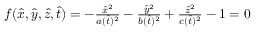<formula> <loc_0><loc_0><loc_500><loc_500>\begin{array} { r } { f ( \hat { x } , \hat { y } , \hat { z } , \hat { t } ) = - \frac { \hat { x } ^ { 2 } } { a ( \hat { t } ) ^ { 2 } } - \frac { \hat { y } ^ { 2 } } { b ( \hat { t } ) ^ { 2 } } + \frac { \hat { z } ^ { 2 } } { c ( \hat { t } ) ^ { 2 } } - 1 = 0 } \end{array}</formula> 